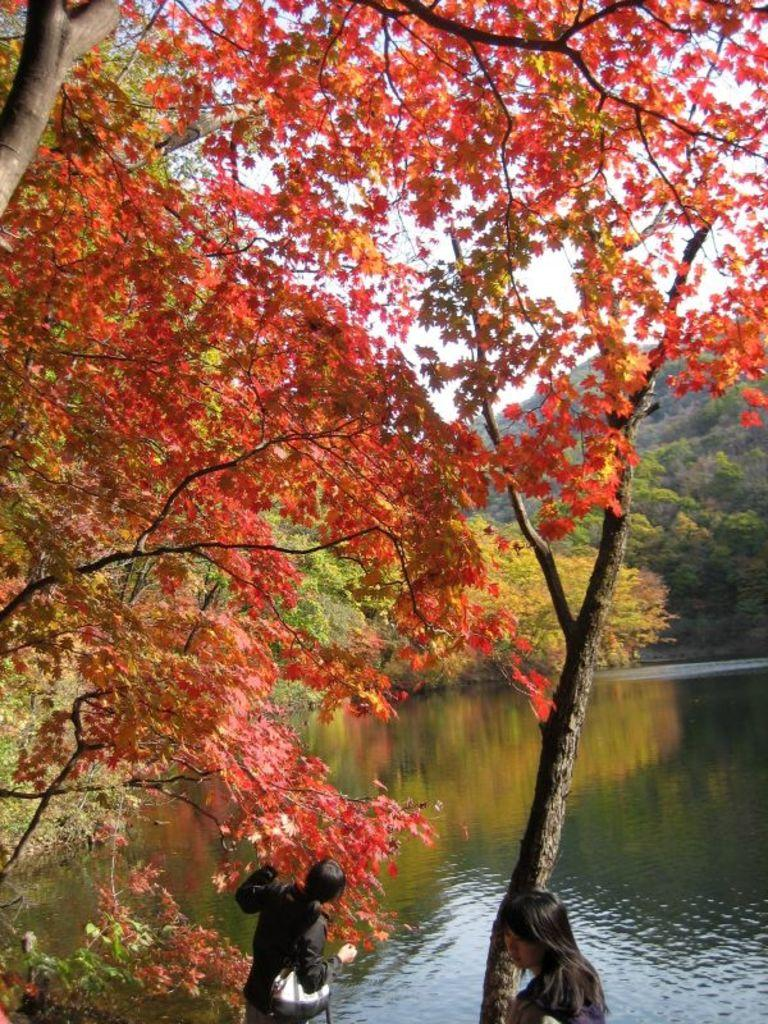What type of vegetation is present in the image? There are trees and grass in the image. What are the women in the image wearing? The women are wearing black dresses. What is visible at the top of the image? The sky is visible at the top of the image. What type of drug can be seen in the image? There is no drug present in the image. What is the aftermath of the event depicted in the image? There is no event depicted in the image, so there is no aftermath to describe. 